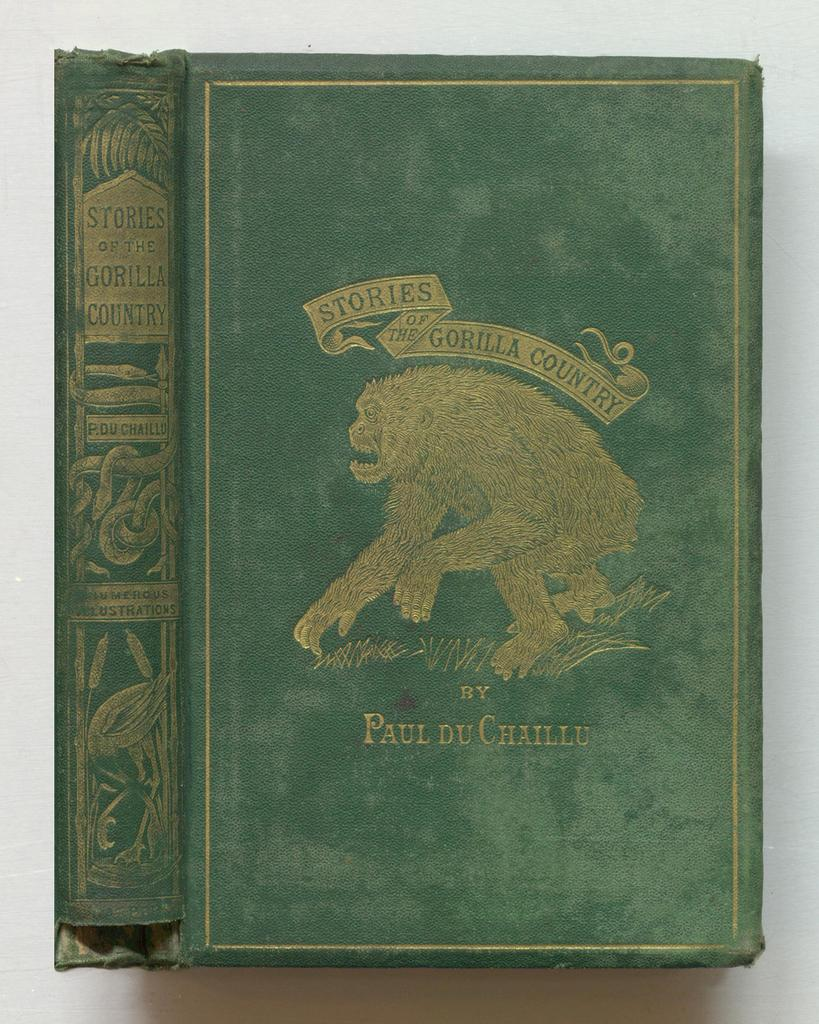<image>
Give a short and clear explanation of the subsequent image. Green book cover for "Stories of the Gorilla Country" showing a gorilla on the cover. 